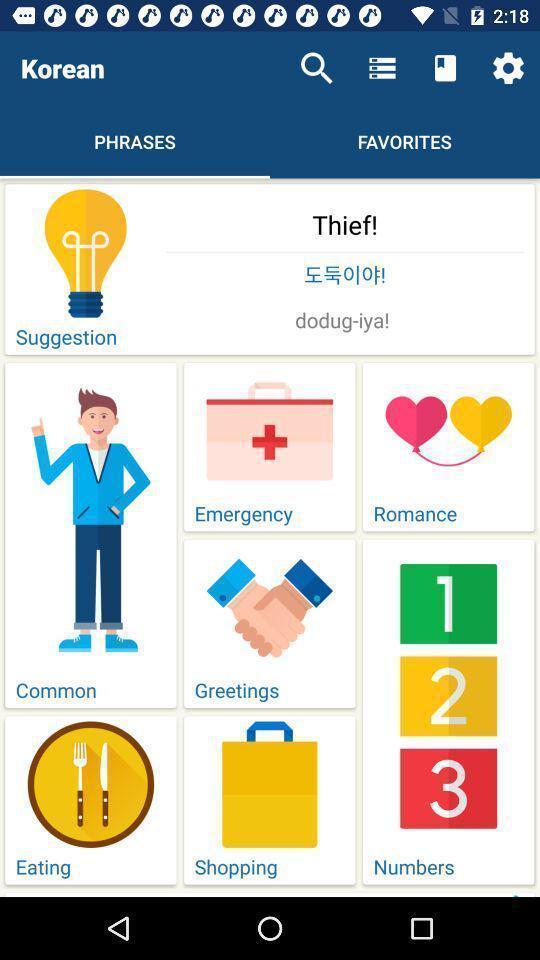Summarize the information in this screenshot. Page displaying list of options in health app. 